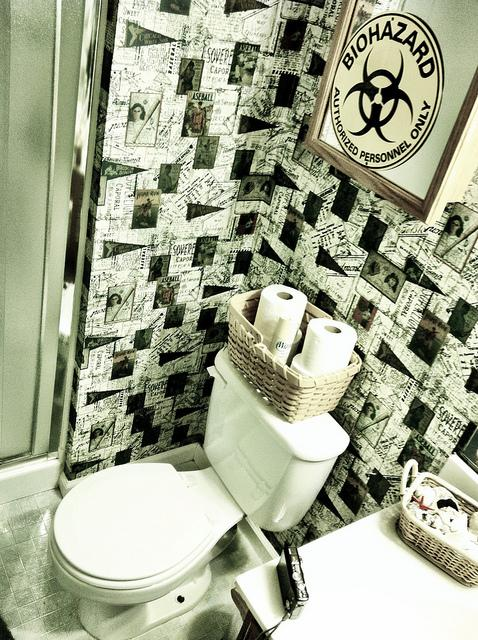What does the sign say?

Choices:
A) biohazard
B) stop
C) garbage
D) proceed biohazard 